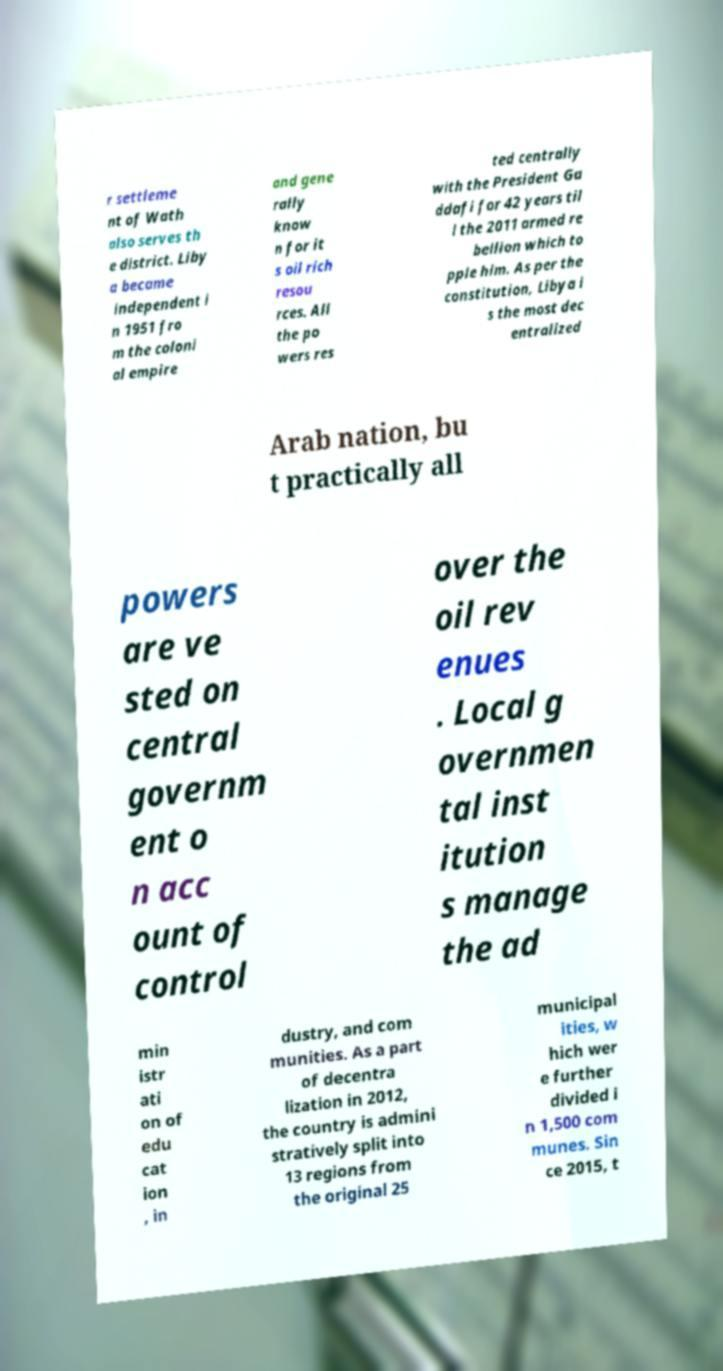Can you accurately transcribe the text from the provided image for me? r settleme nt of Wath also serves th e district. Liby a became independent i n 1951 fro m the coloni al empire and gene rally know n for it s oil rich resou rces. All the po wers res ted centrally with the President Ga ddafi for 42 years til l the 2011 armed re bellion which to pple him. As per the constitution, Libya i s the most dec entralized Arab nation, bu t practically all powers are ve sted on central governm ent o n acc ount of control over the oil rev enues . Local g overnmen tal inst itution s manage the ad min istr ati on of edu cat ion , in dustry, and com munities. As a part of decentra lization in 2012, the country is admini stratively split into 13 regions from the original 25 municipal ities, w hich wer e further divided i n 1,500 com munes. Sin ce 2015, t 